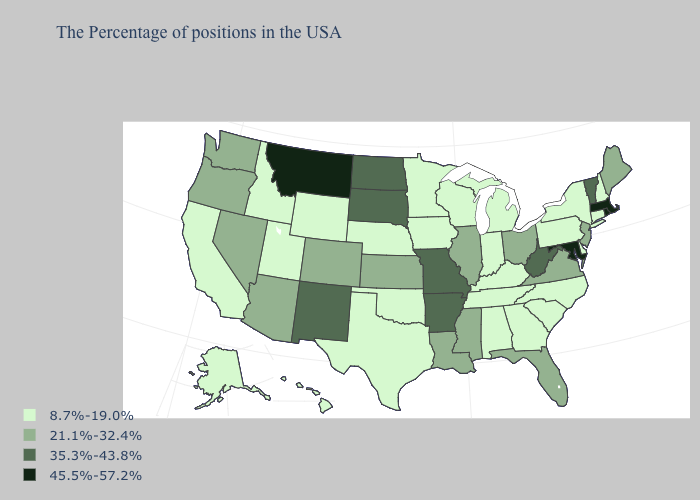What is the value of Montana?
Give a very brief answer. 45.5%-57.2%. Does Texas have the lowest value in the USA?
Be succinct. Yes. What is the highest value in states that border Indiana?
Short answer required. 21.1%-32.4%. What is the value of New Jersey?
Quick response, please. 21.1%-32.4%. Does North Carolina have a lower value than Rhode Island?
Write a very short answer. Yes. How many symbols are there in the legend?
Be succinct. 4. What is the value of Nevada?
Concise answer only. 21.1%-32.4%. Does Arizona have the same value as Delaware?
Quick response, please. No. Name the states that have a value in the range 45.5%-57.2%?
Give a very brief answer. Massachusetts, Rhode Island, Maryland, Montana. What is the value of Virginia?
Concise answer only. 21.1%-32.4%. Does South Carolina have the lowest value in the South?
Be succinct. Yes. Among the states that border Tennessee , does Missouri have the highest value?
Be succinct. Yes. What is the highest value in states that border Oklahoma?
Write a very short answer. 35.3%-43.8%. Which states have the highest value in the USA?
Be succinct. Massachusetts, Rhode Island, Maryland, Montana. 